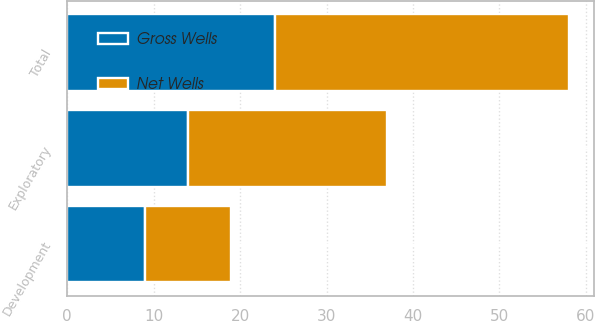<chart> <loc_0><loc_0><loc_500><loc_500><stacked_bar_chart><ecel><fcel>Development<fcel>Exploratory<fcel>Total<nl><fcel>Net Wells<fcel>10<fcel>23<fcel>34<nl><fcel>Gross Wells<fcel>9<fcel>14<fcel>24<nl></chart> 